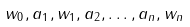Convert formula to latex. <formula><loc_0><loc_0><loc_500><loc_500>w _ { 0 } , a _ { 1 } , w _ { 1 } , a _ { 2 } , \dots , a _ { n } , w _ { n }</formula> 